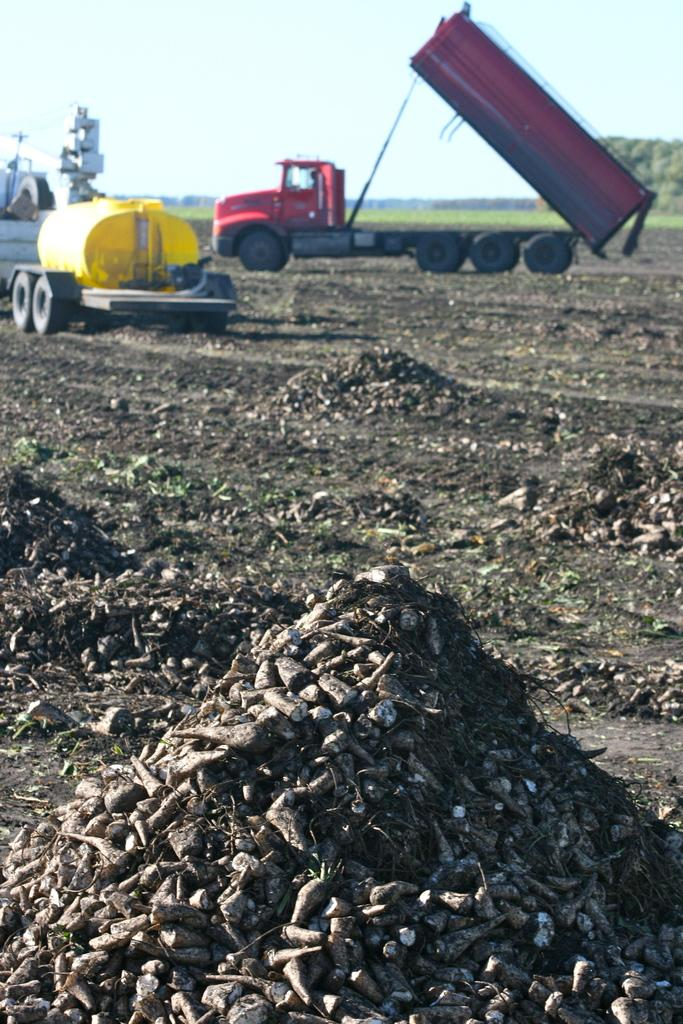What can be seen in the background of the image? There are two vehicles in the background of the image. What type of surface is visible in the image? There is a ground visible in the image. What type of calculator can be seen in the image? There is no calculator present in the image. Is there a church visible in the image? There is no church visible in the image. 